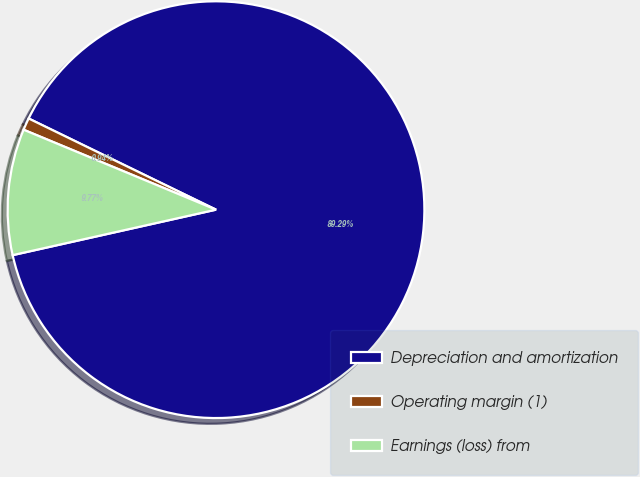Convert chart to OTSL. <chart><loc_0><loc_0><loc_500><loc_500><pie_chart><fcel>Depreciation and amortization<fcel>Operating margin (1)<fcel>Earnings (loss) from<nl><fcel>89.29%<fcel>0.94%<fcel>9.77%<nl></chart> 